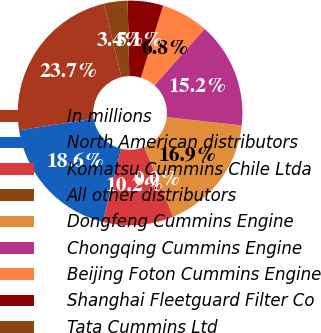<chart> <loc_0><loc_0><loc_500><loc_500><pie_chart><fcel>In millions<fcel>North American distributors<fcel>Komatsu Cummins Chile Ltda<fcel>All other distributors<fcel>Dongfeng Cummins Engine<fcel>Chongqing Cummins Engine<fcel>Beijing Foton Cummins Engine<fcel>Shanghai Fleetguard Filter Co<fcel>Tata Cummins Ltd<nl><fcel>23.72%<fcel>18.64%<fcel>10.17%<fcel>0.01%<fcel>16.94%<fcel>15.25%<fcel>6.78%<fcel>5.09%<fcel>3.4%<nl></chart> 